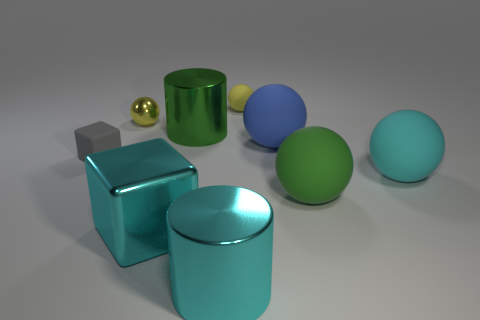Subtract all cyan blocks. How many blocks are left? 1 Subtract all small rubber spheres. How many spheres are left? 4 Subtract all cylinders. How many objects are left? 7 Subtract 1 cylinders. How many cylinders are left? 1 Subtract all big red blocks. Subtract all cyan blocks. How many objects are left? 8 Add 2 small spheres. How many small spheres are left? 4 Add 2 cyan cubes. How many cyan cubes exist? 3 Add 1 tiny rubber cubes. How many objects exist? 10 Subtract 0 green blocks. How many objects are left? 9 Subtract all yellow spheres. Subtract all green blocks. How many spheres are left? 3 